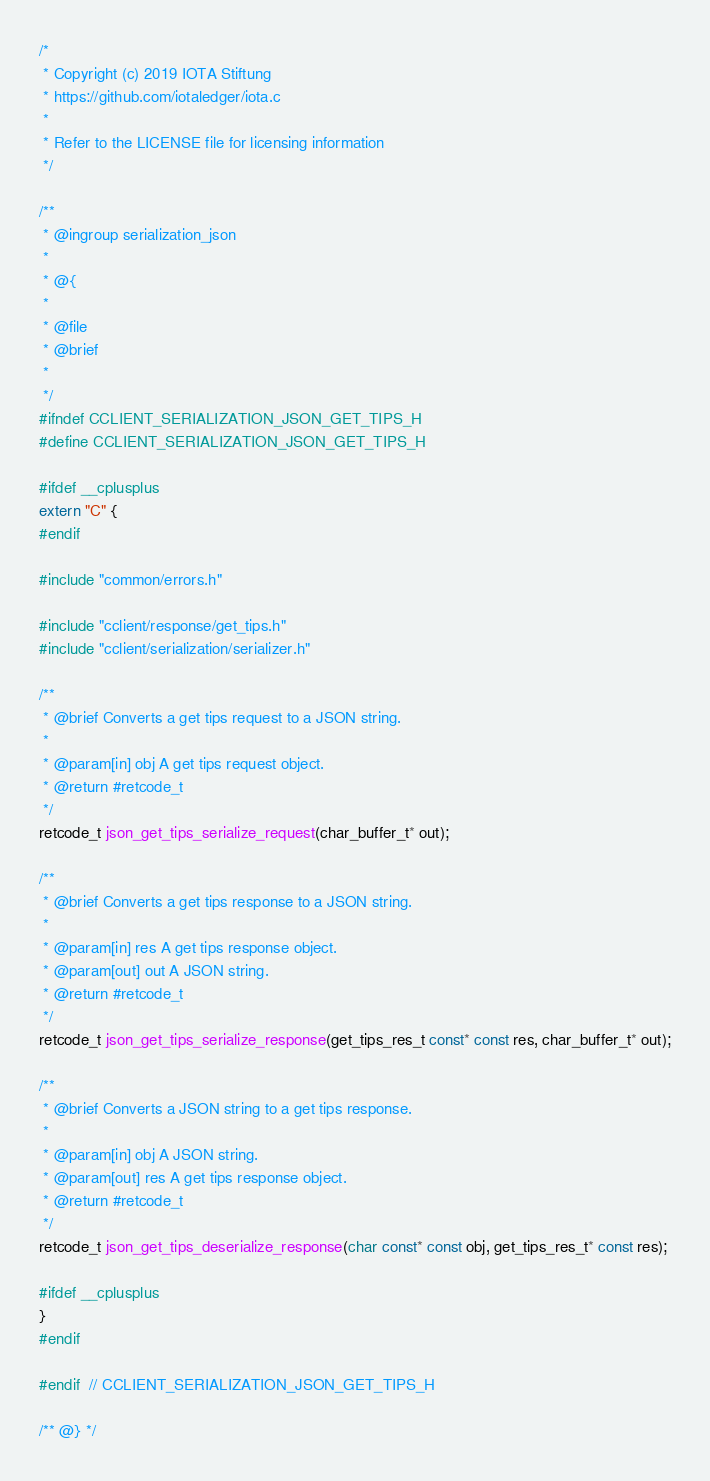<code> <loc_0><loc_0><loc_500><loc_500><_C_>/*
 * Copyright (c) 2019 IOTA Stiftung
 * https://github.com/iotaledger/iota.c
 *
 * Refer to the LICENSE file for licensing information
 */

/**
 * @ingroup serialization_json
 *
 * @{
 *
 * @file
 * @brief
 *
 */
#ifndef CCLIENT_SERIALIZATION_JSON_GET_TIPS_H
#define CCLIENT_SERIALIZATION_JSON_GET_TIPS_H

#ifdef __cplusplus
extern "C" {
#endif

#include "common/errors.h"

#include "cclient/response/get_tips.h"
#include "cclient/serialization/serializer.h"

/**
 * @brief Converts a get tips request to a JSON string.
 *
 * @param[in] obj A get tips request object.
 * @return #retcode_t
 */
retcode_t json_get_tips_serialize_request(char_buffer_t* out);

/**
 * @brief Converts a get tips response to a JSON string.
 *
 * @param[in] res A get tips response object.
 * @param[out] out A JSON string.
 * @return #retcode_t
 */
retcode_t json_get_tips_serialize_response(get_tips_res_t const* const res, char_buffer_t* out);

/**
 * @brief Converts a JSON string to a get tips response.
 *
 * @param[in] obj A JSON string.
 * @param[out] res A get tips response object.
 * @return #retcode_t
 */
retcode_t json_get_tips_deserialize_response(char const* const obj, get_tips_res_t* const res);

#ifdef __cplusplus
}
#endif

#endif  // CCLIENT_SERIALIZATION_JSON_GET_TIPS_H

/** @} */</code> 